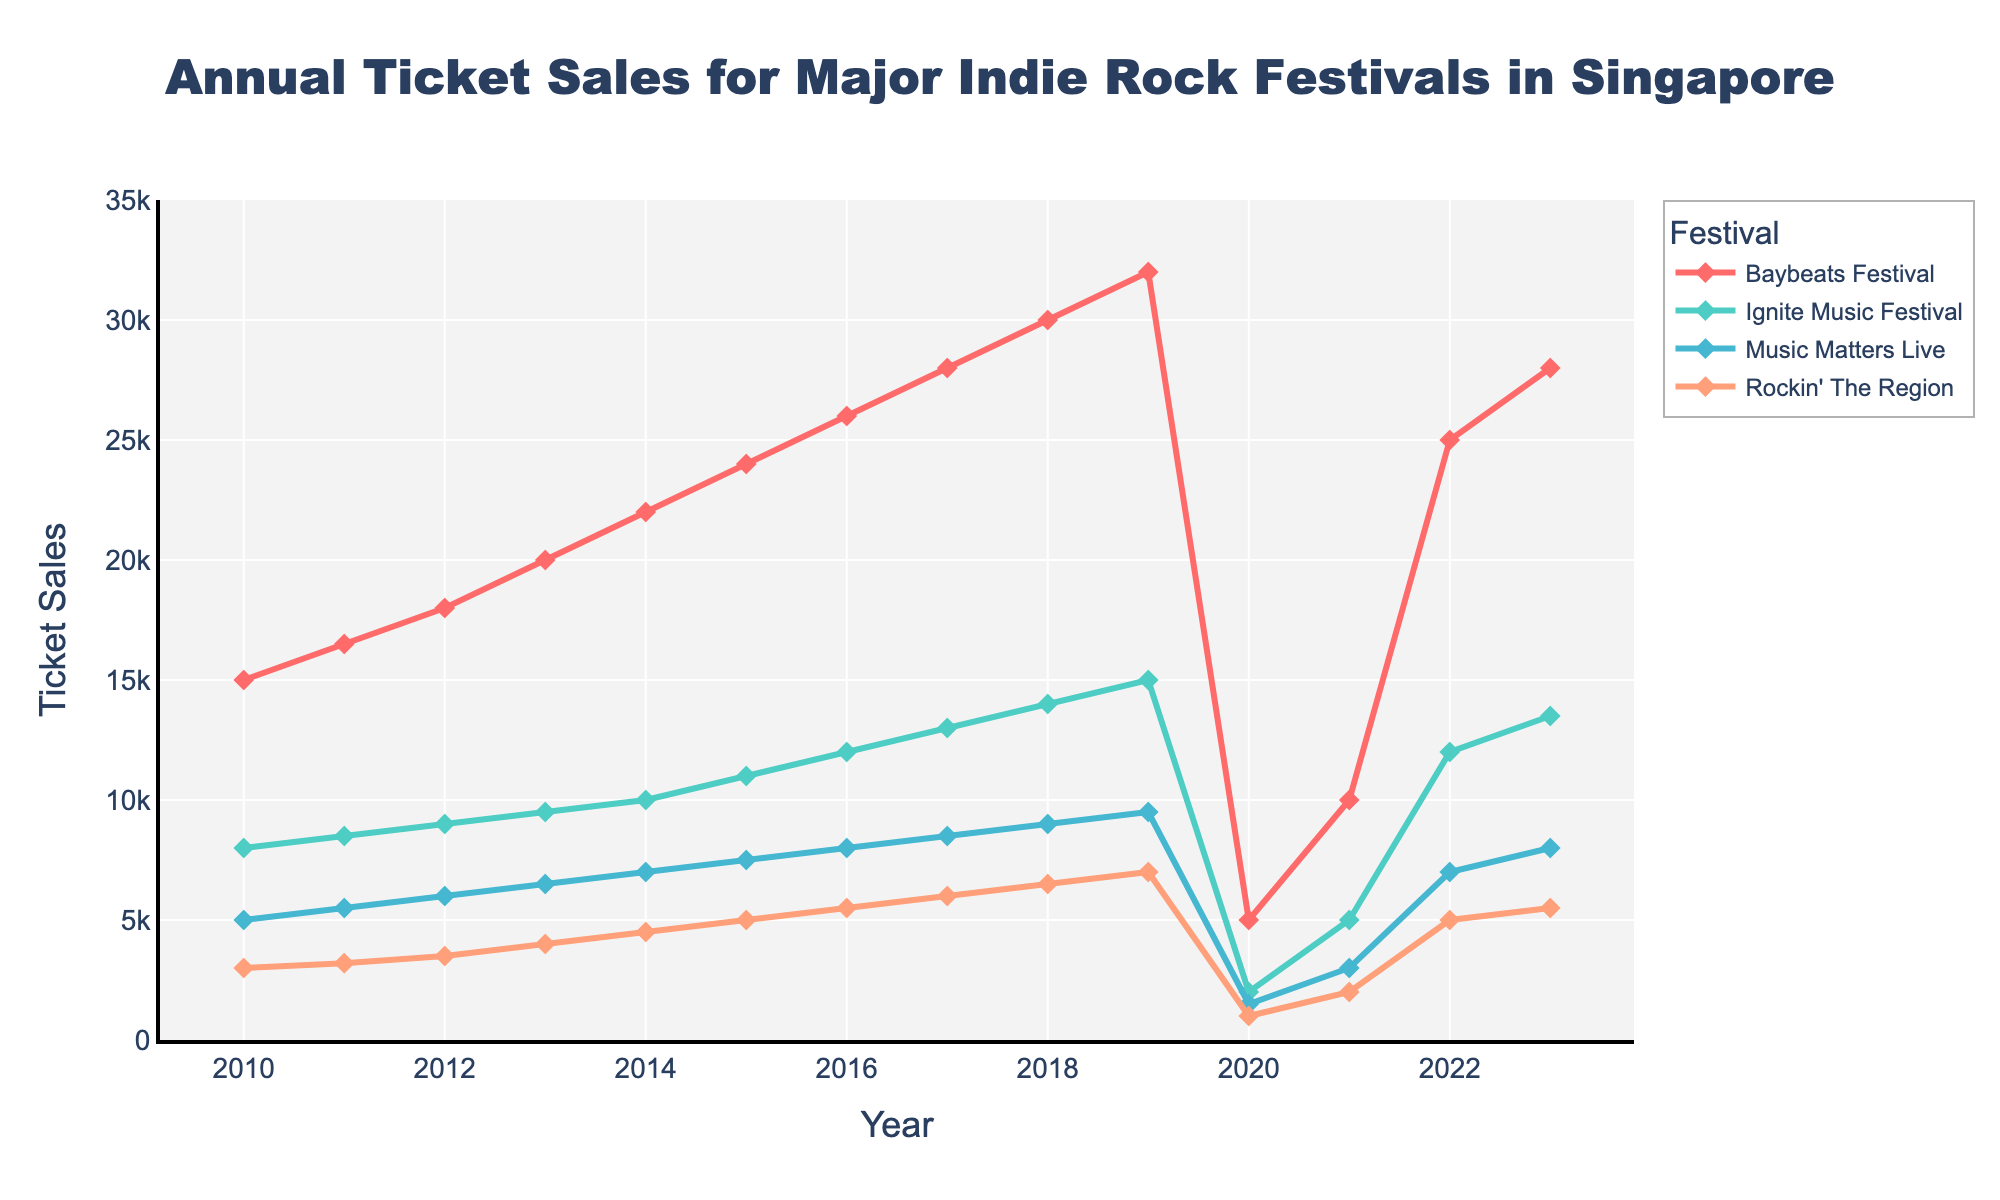What was the ticket sales difference for Baybeats Festival between 2019 and 2020? To find the difference in ticket sales for Baybeats Festival between 2019 and 2020, subtract the 2020 sales from the 2019 sales: 32000 - 5000
Answer: 27000 Which festival had the least ticket sales in 2021 and what was the amount? In 2021, looking at the figures for all festivals: Baybeats Festival (10000), Ignite Music Festival (5000), Music Matters Live (3000), and Rockin' The Region (2000), Rockin' The Region had the least ticket sales with 2000 tickets
Answer: Rockin' The Region, 2000 By how much did the ticket sales for Ignite Music Festival increase from 2010 to 2019? The ticket sales for Ignite Music Festival in 2010 were 8000 and in 2019 were 15000. To find the increase, subtract the 2010 figure from the 2019 figure: 15000 - 8000
Answer: 7000 Did any festival's ticket sales decrease between 2019 and 2020, and if so, how much was the decrease for each? Ticket sales for all festivals decreased between 2019 and 2020: Baybeats Festival (32000 to 5000), Ignite Music Festival (15000 to 2000), Music Matters Live (9500 to 1500), and Rockin' The Region (7000 to 1000). The decreases were 27000, 13000, 8000, and 6000 respectively
Answer: Yes, Baybeats Festival: 27000, Ignite Music Festival: 13000, Music Matters Live: 8000, Rockin' The Region: 6000 When did Music Matters Live achieve its highest ticket sales within the given timeframe? According to the data, the highest ticket sales for Music Matters Live were 9500 in 2019
Answer: 2019 Which festival had the most consistent increase in ticket sales from 2010 to 2019? By observing the trends, Baybeats Festival had the most consistent increase in ticket sales, with values incrementally rising each year from 15000 in 2010 to 32000 in 2019
Answer: Baybeats Festival How did the ticket sales for Rockin' The Region in 2023 compare to its ticket sales in 2010? To compare, check the figures for Rockin' The Region in 2023 (5500) and 2010 (3000). The increase is 5500 - 3000
Answer: Increased by 2500 What was the average ticket sales for Ignite Music Festival from 2010 to 2019? To find the average, sum the ticket sales for each year from 2010 (8000) to 2019 (15000), which equals 124500, then divide by the number of years (10). (8000 + 8500 + 9000 + 9500 + 10000 + 11000 + 12000 + 13000 + 14000 + 15000) / 10 = 124500 / 10
Answer: 12450 For the year 2020, rank the festivals from highest to lowest ticket sales. For 2020, the ticket sales are: Baybeats Festival (5000), Ignite Music Festival (2000), Music Matters Live (1500), and Rockin' The Region (1000), ranked from highest to lowest, the order is: Baybeats Festival, Ignite Music Festival, Music Matters Live, Rockin' The Region
Answer: Baybeats Festival > Ignite Music Festival > Music Matters Live > Rockin' The Region 